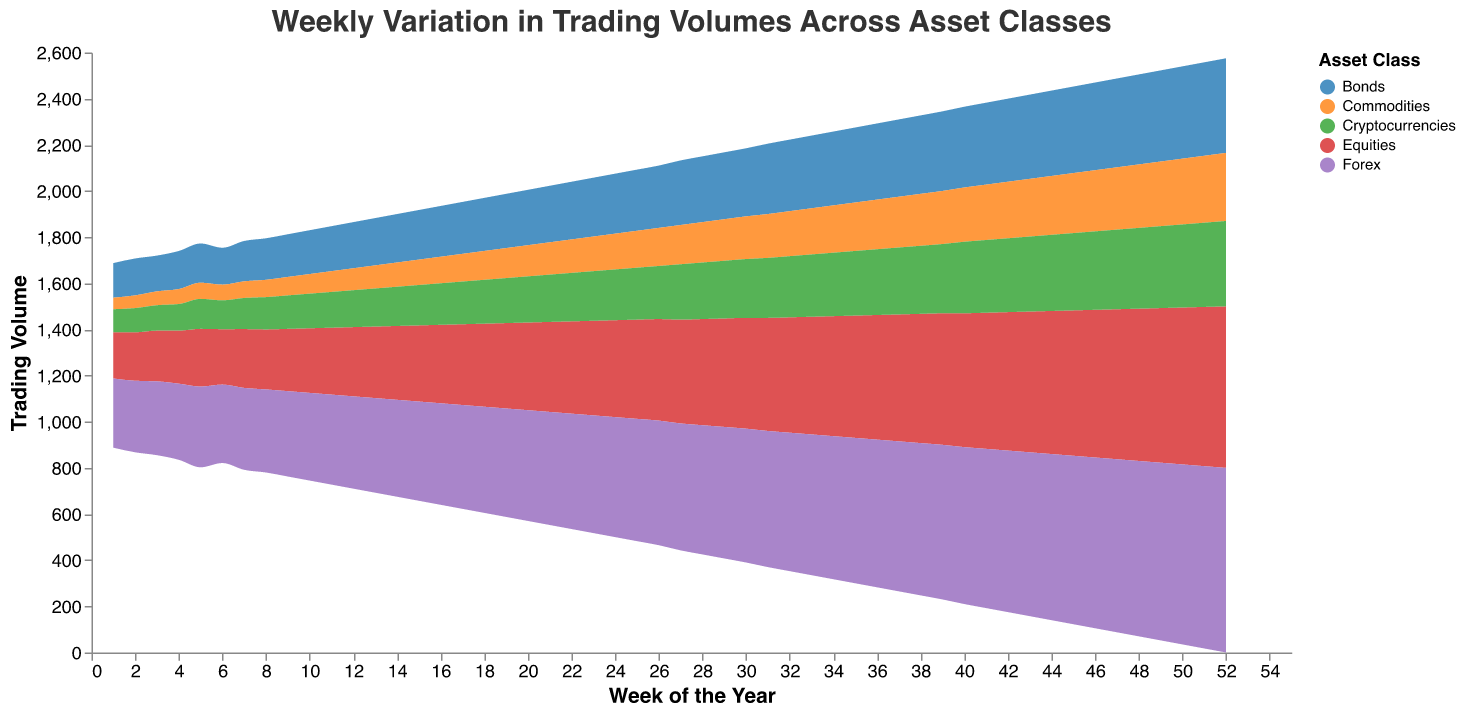What is the title of the plot? The title is displayed at the top of the plot in a readable font.
Answer: Weekly Variation in Trading Volumes Across Asset Classes Which asset class has the highest starting trading volume in Week 1? By examining Week 1, the highest value among the asset classes is Forex with 300.
Answer: Forex How does the trading volume of Equities change from Week 1 to Week 52? By observing the plot, the trading volume of Equities starts at 200 in Week 1 and increases linearly to 700 in Week 52.
Answer: Increases from 200 to 700 Which asset class shows the smallest increase in trading volumes over the year? The plot shows the least pronounced growth in trading volumes for Commodities.
Answer: Commodities What is the total trading volume for Equities and Bonds combined in Week 10? Sum the values of Equities (280) and Bonds (190) in Week 10: 280 + 190 = 470.
Answer: 470 Compare the trading volume of Forex and Cryptocurrencies in Week 25. Which is higher? By checking Week 25, Forex has a trading volume of 530, and Cryptocurrencies have 225. Forex has the higher trading volume.
Answer: Forex During which week does Forex reach a trading volume of 500? Recall the weeks until Forex reaches 500, which occurs in Week 22.
Answer: Week 22 What is the ratio of Equities trading volume to Cryptocurrencies trading volume in Week 35? Divide the trading volume of Equities (530) by Cryptocurrencies (280): 530 / 280 ≈ 1.89.
Answer: 1.89 Between Weeks 15 and 25, which asset classes have shown a consistent increase in trading volume? By examining the plot, Equities, Bonds, Forex, and Cryptocurrencies show a consistent increase. Commodities show a less consistent pattern but generally increase.
Answer: Equities, Bonds, Forex, Cryptocurrencies, Commodities Which asset class exhibits the most volatility in trading volumes throughout the year? By observing the fluctuation in the plotting areas, Cryptocurrencies exhibit more variability compared to others.
Answer: Cryptocurrencies 